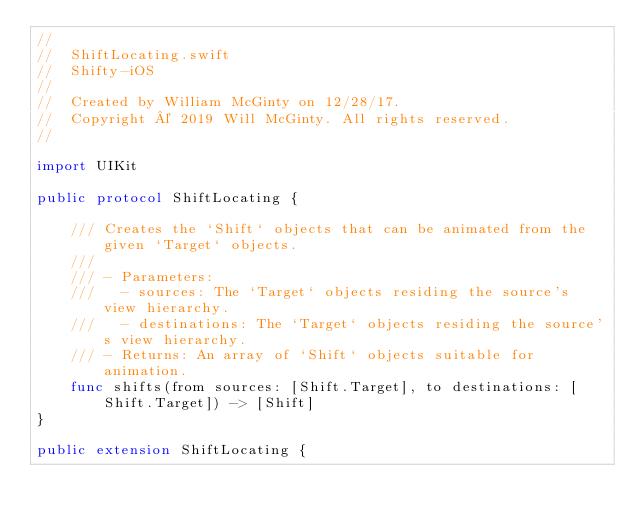<code> <loc_0><loc_0><loc_500><loc_500><_Swift_>//
//  ShiftLocating.swift
//  Shifty-iOS
//
//  Created by William McGinty on 12/28/17.
//  Copyright © 2019 Will McGinty. All rights reserved.
//

import UIKit

public protocol ShiftLocating {
    
    /// Creates the `Shift` objects that can be animated from the given `Target` objects.
    ///
    /// - Parameters:
    ///   - sources: The `Target` objects residing the source's view hierarchy.
    ///   - destinations: The `Target` objects residing the source's view hierarchy.
    /// - Returns: An array of `Shift` objects suitable for animation.
    func shifts(from sources: [Shift.Target], to destinations: [Shift.Target]) -> [Shift]
}

public extension ShiftLocating {
    </code> 